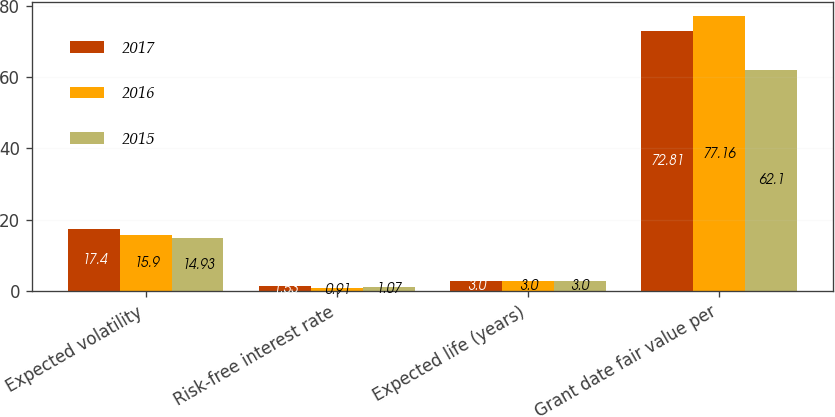<chart> <loc_0><loc_0><loc_500><loc_500><stacked_bar_chart><ecel><fcel>Expected volatility<fcel>Risk-free interest rate<fcel>Expected life (years)<fcel>Grant date fair value per<nl><fcel>2017<fcel>17.4<fcel>1.53<fcel>3<fcel>72.81<nl><fcel>2016<fcel>15.9<fcel>0.91<fcel>3<fcel>77.16<nl><fcel>2015<fcel>14.93<fcel>1.07<fcel>3<fcel>62.1<nl></chart> 